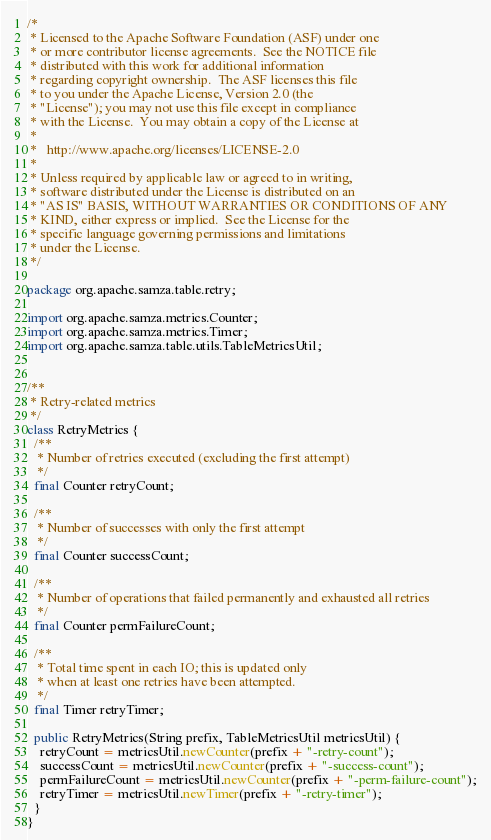<code> <loc_0><loc_0><loc_500><loc_500><_Java_>/*
 * Licensed to the Apache Software Foundation (ASF) under one
 * or more contributor license agreements.  See the NOTICE file
 * distributed with this work for additional information
 * regarding copyright ownership.  The ASF licenses this file
 * to you under the Apache License, Version 2.0 (the
 * "License"); you may not use this file except in compliance
 * with the License.  You may obtain a copy of the License at
 *
 *   http://www.apache.org/licenses/LICENSE-2.0
 *
 * Unless required by applicable law or agreed to in writing,
 * software distributed under the License is distributed on an
 * "AS IS" BASIS, WITHOUT WARRANTIES OR CONDITIONS OF ANY
 * KIND, either express or implied.  See the License for the
 * specific language governing permissions and limitations
 * under the License.
 */

package org.apache.samza.table.retry;

import org.apache.samza.metrics.Counter;
import org.apache.samza.metrics.Timer;
import org.apache.samza.table.utils.TableMetricsUtil;


/**
 * Retry-related metrics
 */
class RetryMetrics {
  /**
   * Number of retries executed (excluding the first attempt)
   */
  final Counter retryCount;

  /**
   * Number of successes with only the first attempt
   */
  final Counter successCount;

  /**
   * Number of operations that failed permanently and exhausted all retries
   */
  final Counter permFailureCount;

  /**
   * Total time spent in each IO; this is updated only
   * when at least one retries have been attempted.
   */
  final Timer retryTimer;

  public RetryMetrics(String prefix, TableMetricsUtil metricsUtil) {
    retryCount = metricsUtil.newCounter(prefix + "-retry-count");
    successCount = metricsUtil.newCounter(prefix + "-success-count");
    permFailureCount = metricsUtil.newCounter(prefix + "-perm-failure-count");
    retryTimer = metricsUtil.newTimer(prefix + "-retry-timer");
  }
}
</code> 